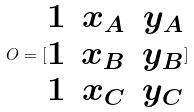<formula> <loc_0><loc_0><loc_500><loc_500>O = [ \begin{matrix} 1 & x _ { A } & y _ { A } \\ 1 & x _ { B } & y _ { B } \\ 1 & x _ { C } & y _ { C } \end{matrix} ]</formula> 